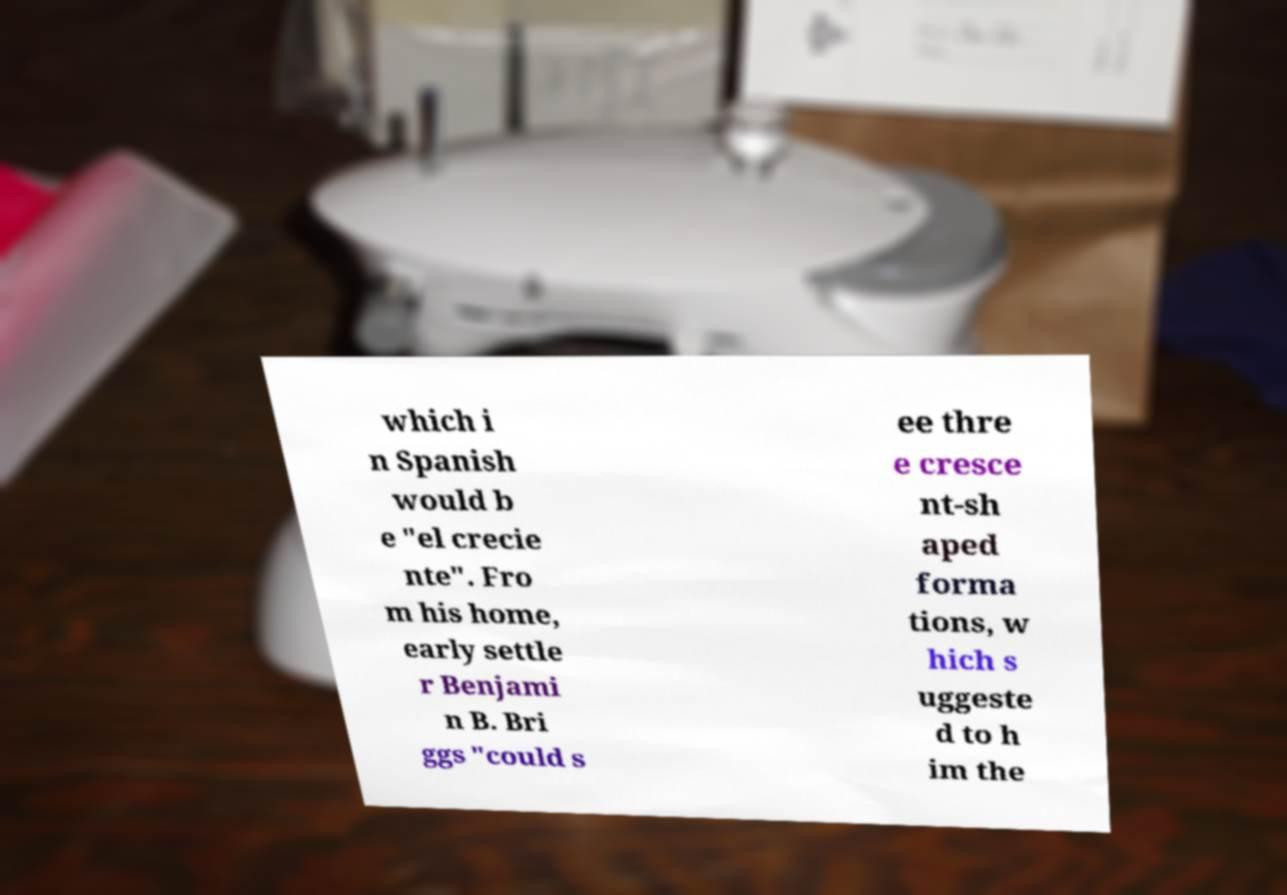What messages or text are displayed in this image? I need them in a readable, typed format. which i n Spanish would b e "el crecie nte". Fro m his home, early settle r Benjami n B. Bri ggs "could s ee thre e cresce nt-sh aped forma tions, w hich s uggeste d to h im the 